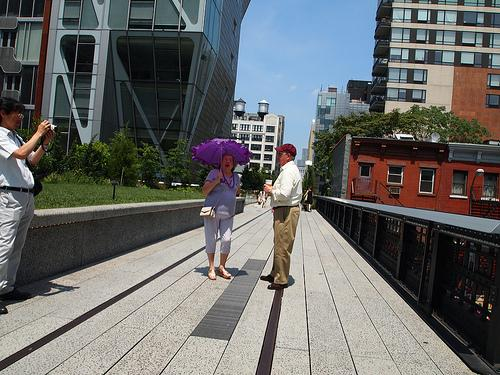Identify any notable clothing items or accessories worn by the man with the red hat. The man is wearing a burgundy/red hat on his head and holding a coffee cup in his hand. Briefly describe the man taking a picture and his position in the image. An Asian man is standing on the left side of the image, wearing white pants, and taking a picture with a camera. Assess the overall image sentiment and emotional aspects present in the scene. The image evokes a calm and pleasant sentiment with people enjoying a sunny day outdoors in the city with clear blue skies. Count the number of people that are standing in the image and their respective activities. There are three people standing; one woman holds an umbrella, one man takes a picture, and another man stands with a coffee cup. Examine the image's background and identify distinct features of the landscape or cityscape. The image's background features tall buildings with many windows, large green leafy trees, bushes along the walkway, and a black railing beside the walkway. Based on the image, describe the attire of the man standing next to the woman with the purple umbrella. The man is wearing a white shirt, beige pants, and a red hat, while holding a coffee cup in his hand. Describe the location and time of day captured in the image. The picture was taken outside during the day in the city, with a clear blue sky and no clouds. In the context of the image, what is the primary purpose of the long sidewalk and its surroundings? The long sidewalk is a walkway for people to move through and interact within the urban environment, surrounded by green spaces and buildings. What accessories are the woman with the purple parasol carrying with her? The woman is carrying a small beige purse and holding a purple umbrella with ruffled edges. Analyze the relationship between the people and the spatial landscape elements in the image. An older couple is standing in the middle of a city walkway with black railing and greenery, while another man takes a photo nearby. Count how many people are standing in the image. There are three people standing in the image. Do you see the green and purple striped kite flying in this scene? No, it's not mentioned in the image. Segment the image into its different semantic regions. Different regions include the sky, buildings, walkway, trees, railing, and people. Are there any unexpected objects or anomalies in the image? No, there are no unexpected objects or anomalies in the image. Is there a person taking a picture in the image? Yes, there is a man on the left taking a picture with a camera. What type of trees are present in the background? There are large green leafy trees near the buildings. Which person is holding a coffee cup? The man with a red hat is holding a coffee cup. Detect the objects in the scene related to photography. The objects related to photography are the man taking a picture with a camera. How would you assess the overall quality of the image in terms of clarity and visibility of objects? The overall image quality is good due to the clarity and visibility of objects. Identify the type of hat the man standing next to the woman is wearing. The man is wearing a red or burgundy hat. Describe the woman's outfit in the image. The woman is wearing a beige capri pants, holding a purple parasol, and carrying a small beige purse. What is the main color of the sky in the image? The main color of the sky is blue. Explain the presence of shadows in the image. The shadows are formed due to the sunlight, particularly the shadow of the man taking a picture. Describe the sentiment of the image considering the weather, colors, and overall scene. The image has a positive sentiment with clear weather, vibrant colors, and a cheerful scene. Is there a bench or any seating arrangement on the walkway? No, there is no bench or seating arrangement on the walkway. Identify any text appearing in the image with their locations. There is no text appearing in the image. What are the outfits of the two men in the image? One man is wearing a white shirt, beige pants, and a red hat while holding a coffee cup. The other man is wearing white pants and taking a picture with a camera. What is the theme of the picture? The theme of the picture is an outdoor daytime scene with people engaged in various activities on a walkway. What color is the purse the woman is carrying? The purse is beige in color. What does the walkway consist of? The walkway consists of wood planks and is bordered by a black railing. Identify the objects that are directly interacting with the woman. The objects interacting with the woman are the purple parasol and the small beige purse. 